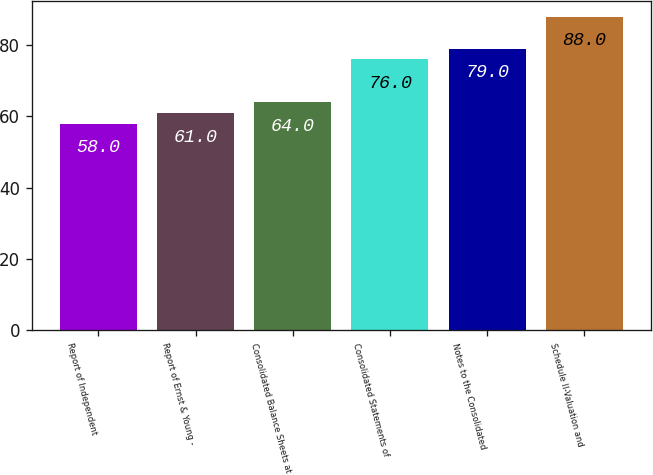<chart> <loc_0><loc_0><loc_500><loc_500><bar_chart><fcel>Report of Independent<fcel>Report of Ernst & Young -<fcel>Consolidated Balance Sheets at<fcel>Consolidated Statements of<fcel>Notes to the Consolidated<fcel>Schedule II-Valuation and<nl><fcel>58<fcel>61<fcel>64<fcel>76<fcel>79<fcel>88<nl></chart> 